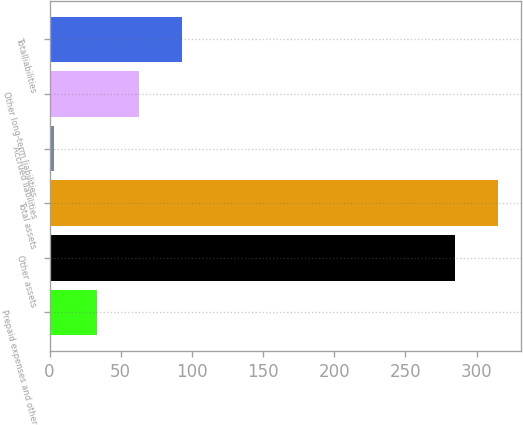<chart> <loc_0><loc_0><loc_500><loc_500><bar_chart><fcel>Prepaid expenses and other<fcel>Other assets<fcel>Total assets<fcel>Accrued liabilities<fcel>Other long-term liabilities<fcel>Totalliabilities<nl><fcel>33.05<fcel>285.1<fcel>315.05<fcel>3.1<fcel>63<fcel>92.95<nl></chart> 